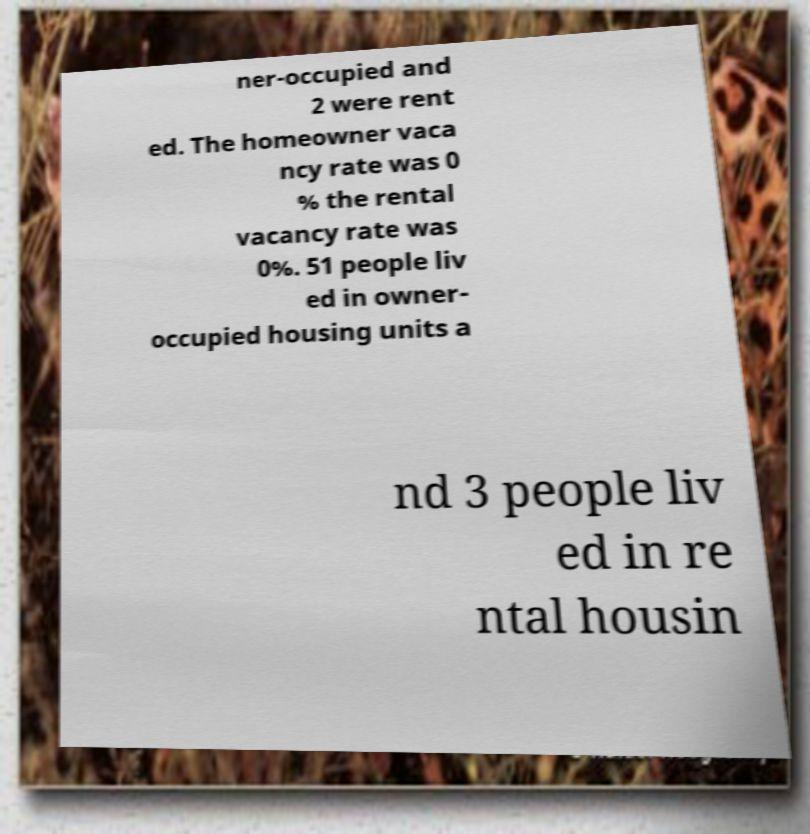Can you accurately transcribe the text from the provided image for me? ner-occupied and 2 were rent ed. The homeowner vaca ncy rate was 0 % the rental vacancy rate was 0%. 51 people liv ed in owner- occupied housing units a nd 3 people liv ed in re ntal housin 